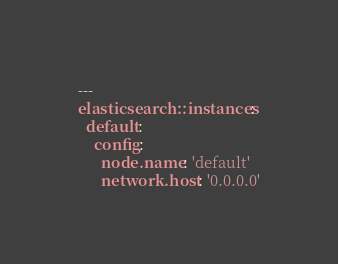<code> <loc_0><loc_0><loc_500><loc_500><_YAML_>---
elasticsearch::instances:
  default:
    config:
      node.name: 'default'
      network.host: '0.0.0.0'
</code> 